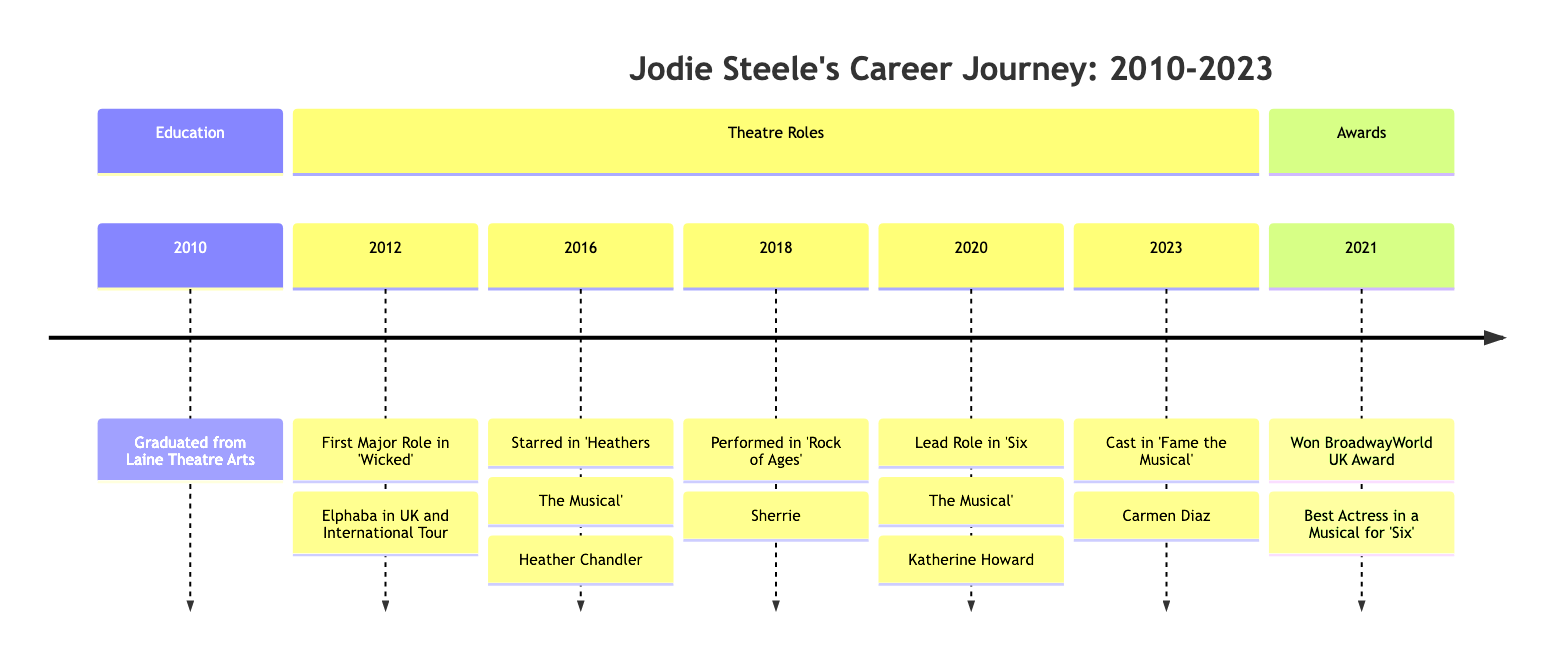What year did Jodie Steele graduate from Laine Theatre Arts? The diagram indicates that Jodie Steele graduated from Laine Theatre Arts in the year 2010, as shown in the Education section.
Answer: 2010 In which musical did Jodie Steele first play the role of Elphaba? According to the Theatre Roles section, Jodie Steele's first major role as Elphaba was in 'Wicked,' which is specifically mentioned next to the year 2012.
Answer: Wicked What award did Jodie Steele win in 2021? The timeline shows under the Awards section that Jodie Steele won the BroadwayWorld UK Award in 2021, and specifically for Best Actress in a Musical.
Answer: BroadwayWorld UK Award How many major roles are listed in the diagram? By counting the entries in the Theatre Roles section, there are five major roles listed, which includes roles from 2012 to 2023.
Answer: 5 Which role did Jodie Steele perform in 'Heathers: The Musical'? The diagram details that in 2016, Jodie Steele starred as Heather Chandler in 'Heathers: The Musical.'
Answer: Heather Chandler What is the relationship between the role in 'Six: The Musical' and the BroadwayWorld UK Award? The diagram indicates that Jodie Steele played Katherine Howard in 'Six: The Musical' in 2020 and subsequently won the BroadwayWorld UK Award for Best Actress in a Musical in 2021, showcasing a direct connection between the role performed and the award received.
Answer: Direct connection In what year did Jodie Steele get cast in 'Fame the Musical'? The timeline states that Jodie Steele was cast in 'Fame the Musical' in 2023, as mentioned in the Theatre Roles section.
Answer: 2023 What can be inferred about Jodie Steele's career trajectory from 2010 to 2023? Analyzing the timeline, it can be inferred that Jodie Steele experienced significant growth in her career, moving from education to major roles in prominent productions and receiving awards, indicating her rising prominence in the musical theatre scene.
Answer: Significant growth Which role solidified Jodie Steele's status as a rising star? The timeline specifies that her role as Heather Chandler in 'Heathers: The Musical' in 2016 gained her widespread acclaim and solidified her status in the industry.
Answer: Heather Chandler 